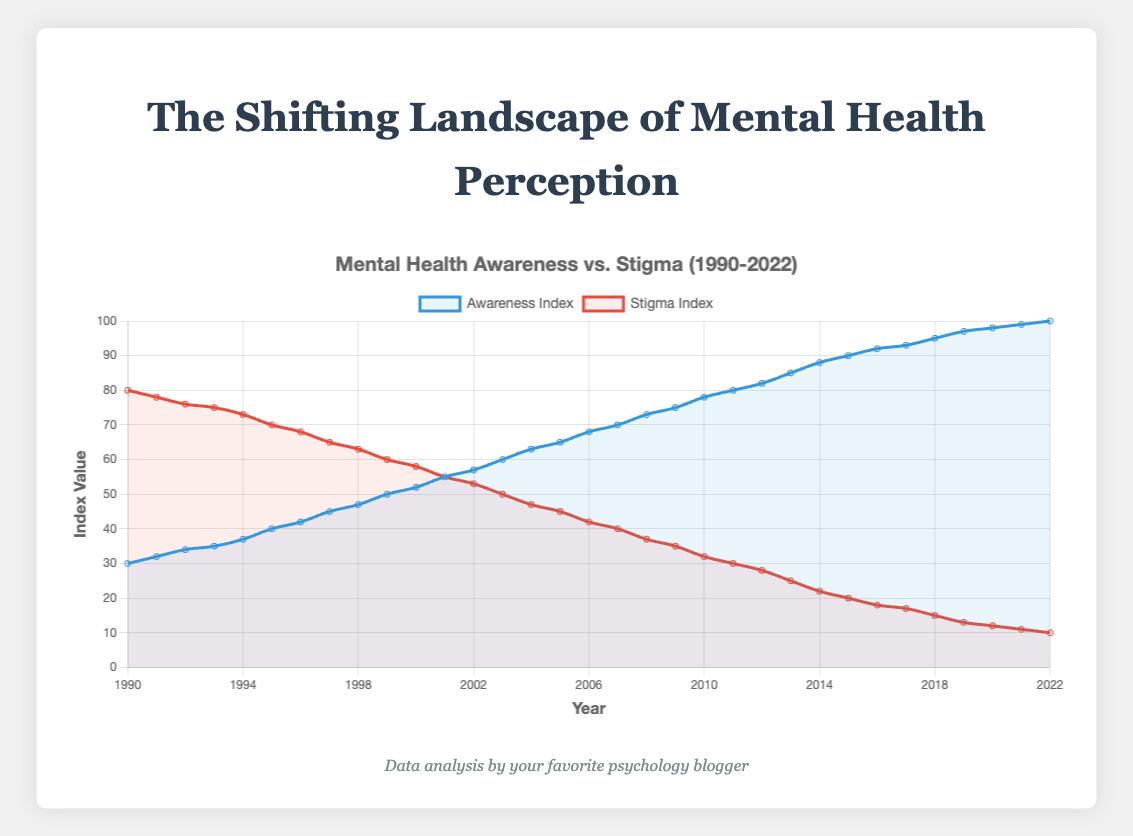What is the average Awareness Index from 1990 to 2022? Sum of Awareness Index values for each year from 1990 to 2022 is 2140. There are 33 years, so 2140 divided by 33 gives approximately 64.85.
Answer: 64.85 In which year do the Awareness Index and Stigma Index have equal values? By observing the line plot, Awareness Index and Stigma Index are equal in 2001 when they both have a value of 55.
Answer: 2001 How many years did it take from the beginning of the data series until the Awareness Index surpassed 50? Awareness Index surpasses 50 in 1999. Since the data series starts in 1990, it took 9 years to surpass 50.
Answer: 9 years Between which two consecutive years did the Awareness Index have the highest increase? The largest increase in the Awareness Index occurred between 2010 (78) and 2011 (80), which is an increase of 2.
Answer: 2010 to 2011 What is the difference between the Stigma Index in 1990 and 2022? Stigma Index in 1990 is 80 and in 2022 is 10. The difference is 80 - 10 = 70.
Answer: 70 In which year does the Awareness Index reach 100? According to the plot, the Awareness Index reaches 100 in the year 2022.
Answer: 2022 Is there any year where both indices are static and show no change from the previous year? Observing the data, there is no year where both the Awareness Index and Stigma Index are static (show no change) from the previous year.
Answer: No What is the trend in the Stigma Index from 1990 to 2022? The trend shows that the Stigma Index continuously decreases from 80 in 1990 to 10 in 2022, indicating a decline in stigma regarding mental health issues over the period.
Answer: Decreasing 